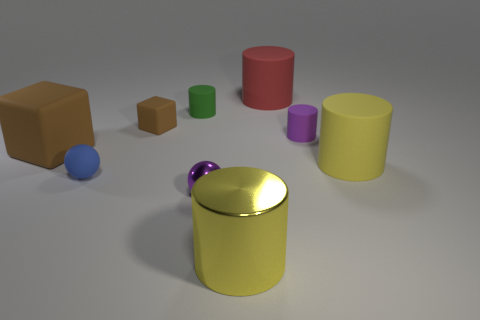Subtract 2 cylinders. How many cylinders are left? 3 Subtract all red cylinders. How many cylinders are left? 4 Subtract all yellow rubber cylinders. How many cylinders are left? 4 Subtract all green cylinders. Subtract all yellow cubes. How many cylinders are left? 4 Add 1 tiny purple metallic spheres. How many objects exist? 10 Subtract all cubes. How many objects are left? 7 Subtract 1 purple cylinders. How many objects are left? 8 Subtract all large yellow metal objects. Subtract all small purple matte cylinders. How many objects are left? 7 Add 7 yellow cylinders. How many yellow cylinders are left? 9 Add 8 large purple rubber things. How many large purple rubber things exist? 8 